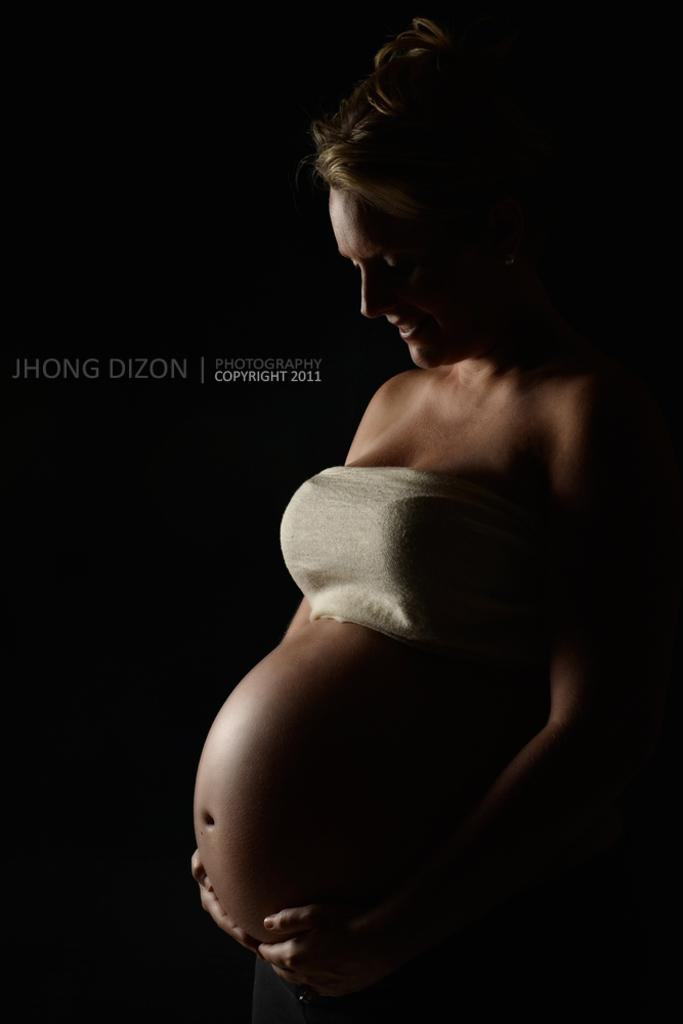Who is present in the image? There is a woman in the image. What expression does the woman have? The woman is smiling. What is the woman doing with her hands in the image? The woman is touching her womb with her hands. What type of system is the woman using to pull the goldfish in the image? There is no system or goldfish present in the image. 